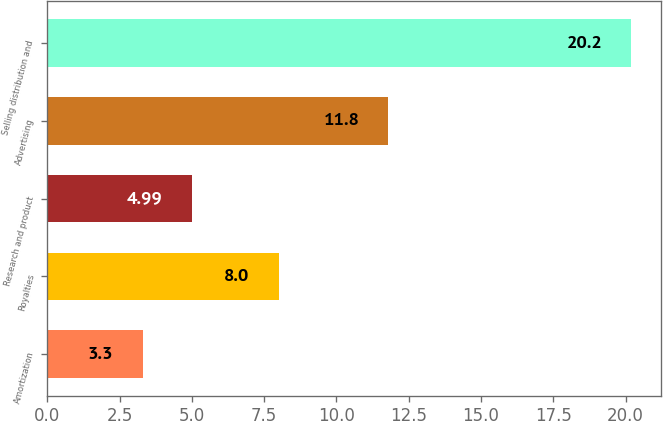Convert chart. <chart><loc_0><loc_0><loc_500><loc_500><bar_chart><fcel>Amortization<fcel>Royalties<fcel>Research and product<fcel>Advertising<fcel>Selling distribution and<nl><fcel>3.3<fcel>8<fcel>4.99<fcel>11.8<fcel>20.2<nl></chart> 